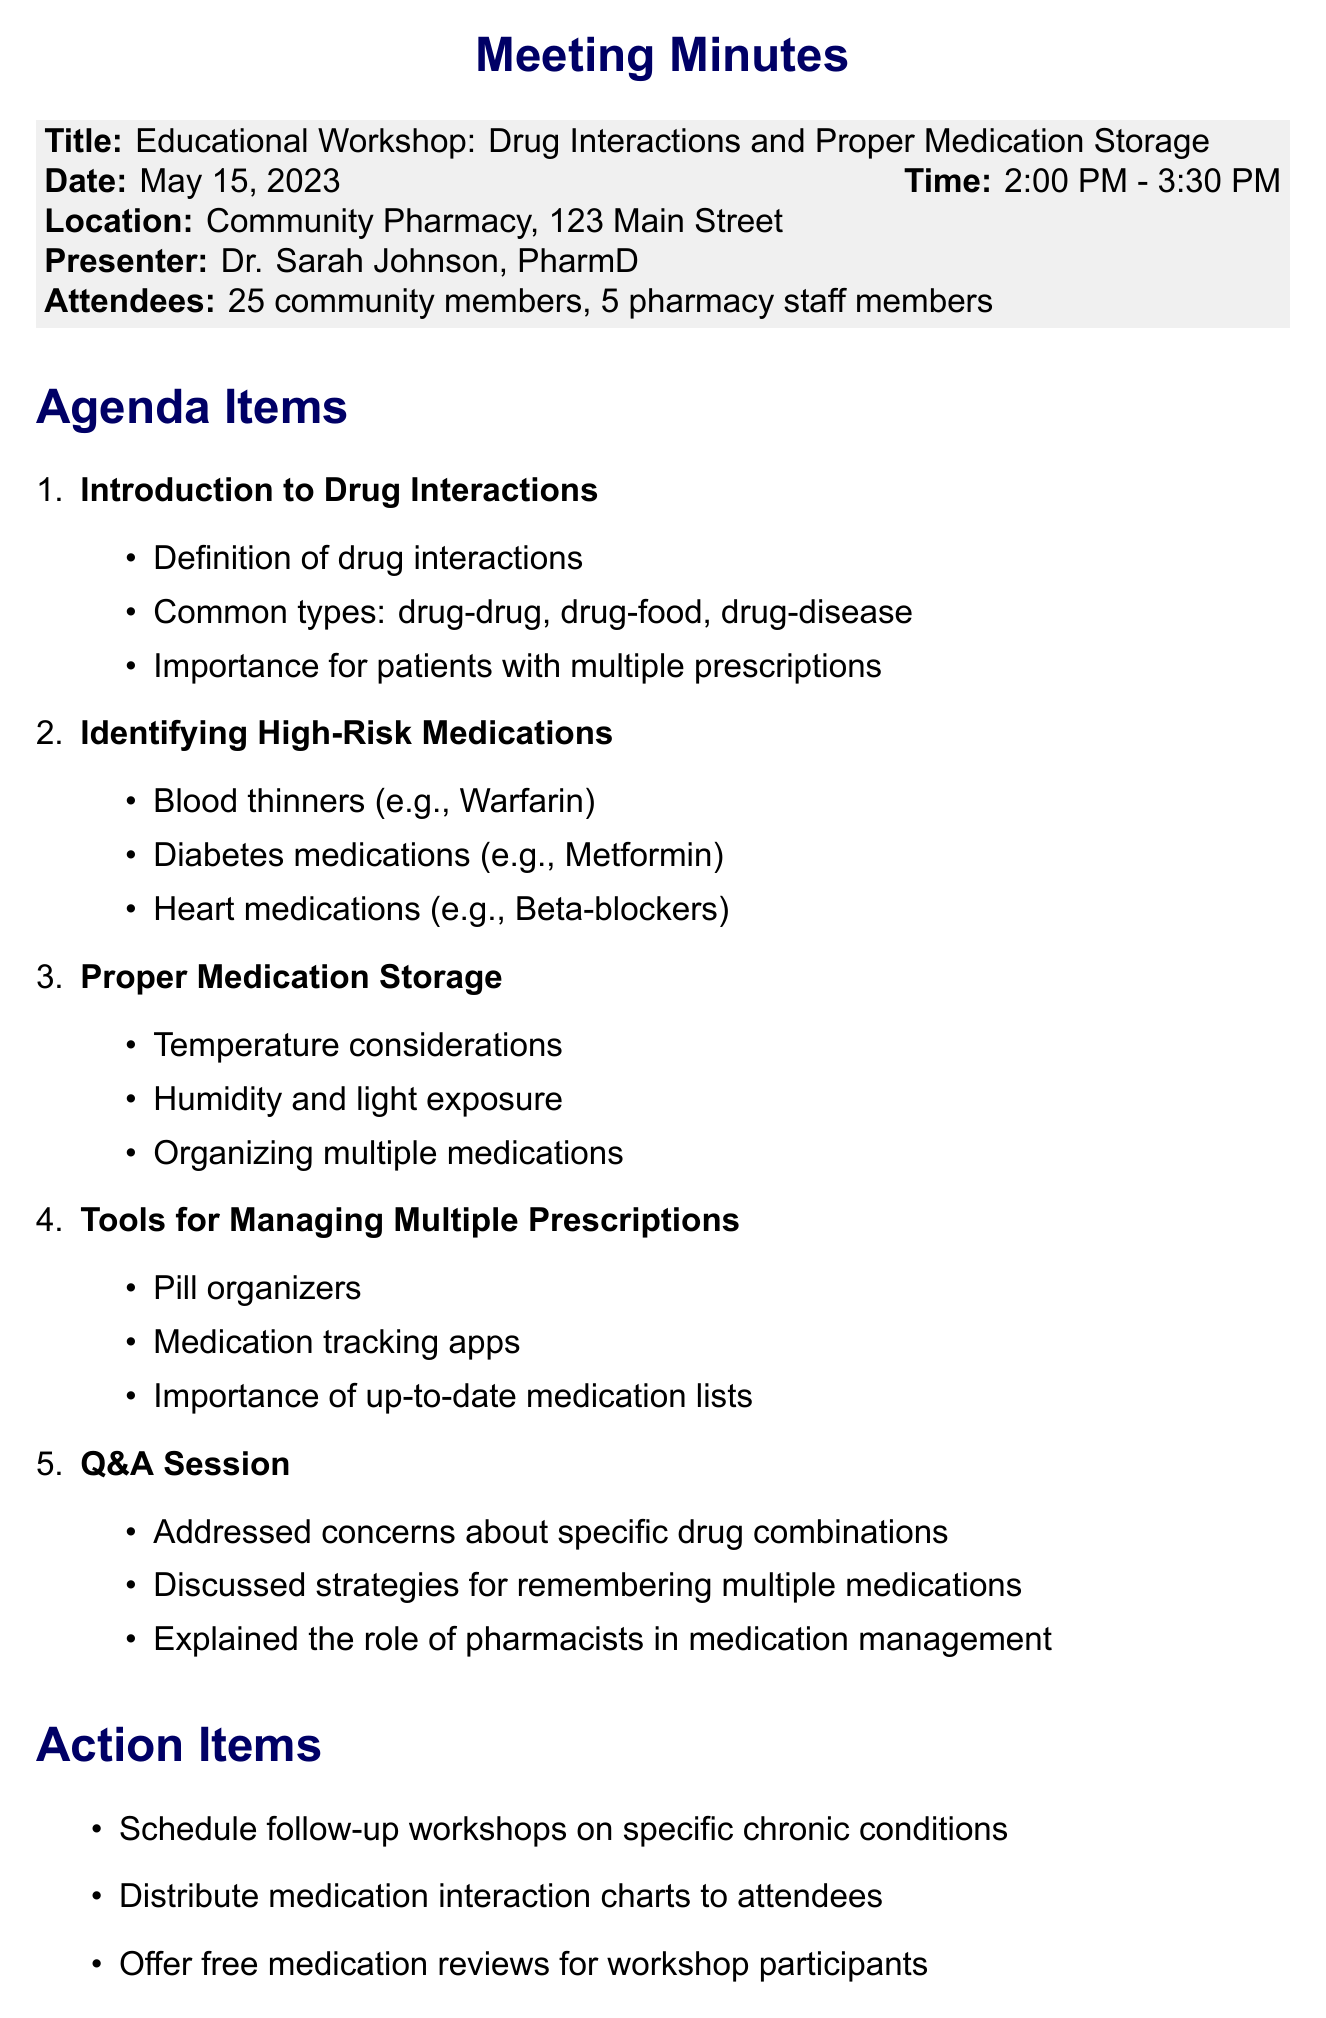what was the date of the workshop? The date of the workshop is provided in the document and is May 15, 2023.
Answer: May 15, 2023 who was the presenter at the workshop? The presenter's name is listed in the document as Dr. Sarah Johnson, PharmD.
Answer: Dr. Sarah Johnson, PharmD how many community members attended the workshop? The document states the number of community members who attended as 25.
Answer: 25 what topic involves strategies for remembering medications? This topic is discussed in the Q&A session of the workshop agenda.
Answer: Q&A Session what is one high-risk medication mentioned in the workshop? The document lists several high-risk medications; one example is Warfarin.
Answer: Warfarin how long was the workshop session? The total duration of the workshop is provided in the document as 1 hour and 30 minutes.
Answer: 1 hour and 30 minutes what is one resource provided to attendees? The document lists resources provided, including a medication interaction guide.
Answer: Medication interaction guide what action item involves follow-up workshops? This refers to the action item scheduled for follow-up workshops on specific chronic conditions.
Answer: follow-up workshops on specific chronic conditions 